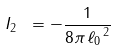Convert formula to latex. <formula><loc_0><loc_0><loc_500><loc_500>I _ { 2 } \ = - \frac { 1 } { 8 \pi \, { \ell _ { 0 } } ^ { \, 2 } }</formula> 